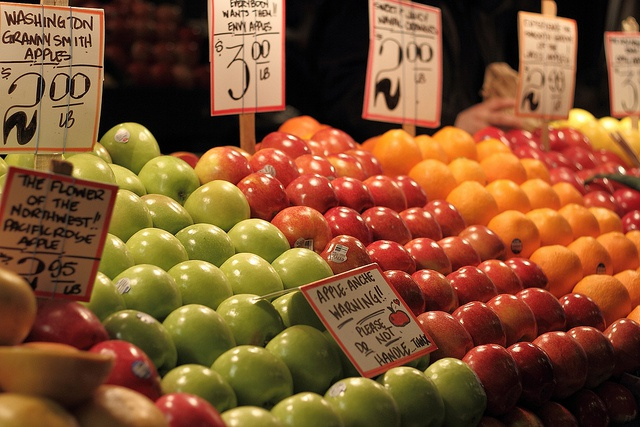Describe the objects in this image and their specific colors. I can see apple in black, olive, and khaki tones, apple in black, maroon, brown, and red tones, orange in black, red, orange, and brown tones, and apple in black, maroon, and brown tones in this image. 